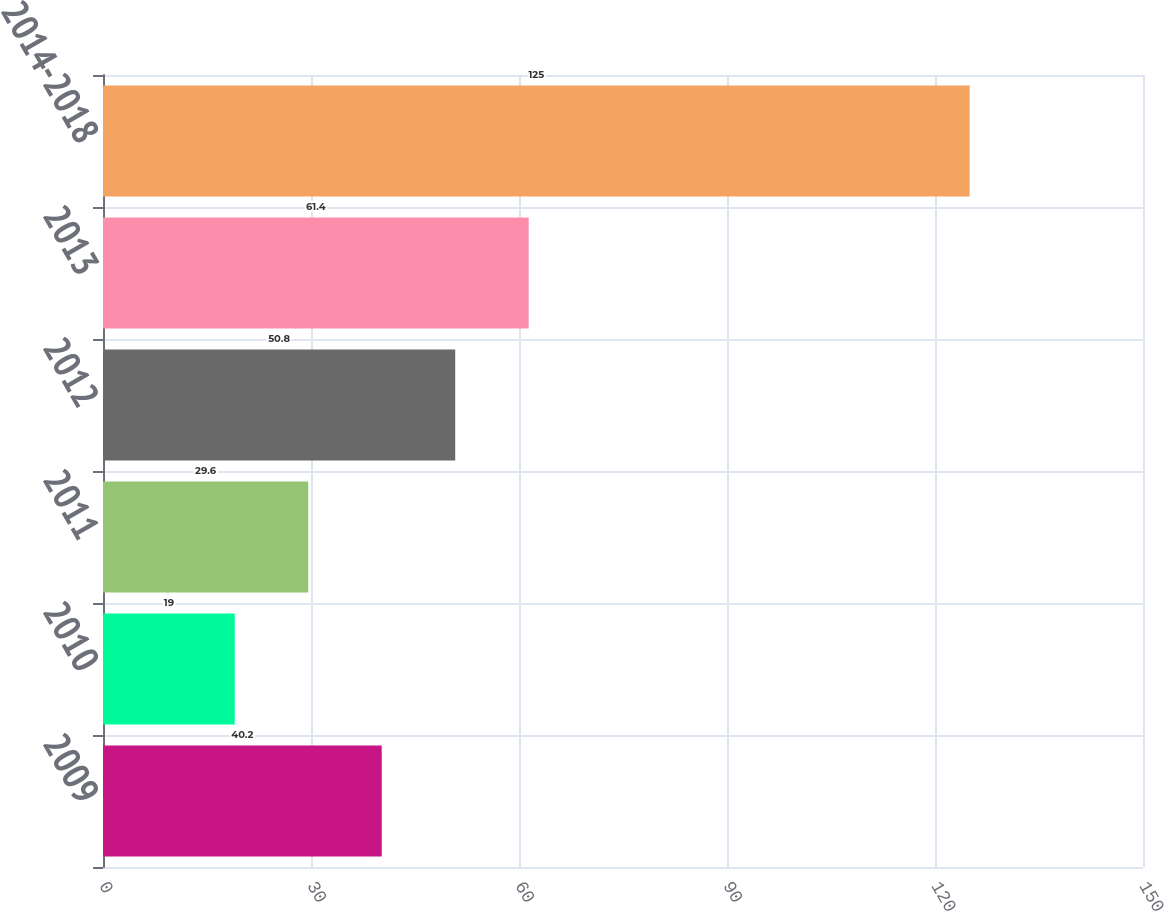Convert chart. <chart><loc_0><loc_0><loc_500><loc_500><bar_chart><fcel>2009<fcel>2010<fcel>2011<fcel>2012<fcel>2013<fcel>2014-2018<nl><fcel>40.2<fcel>19<fcel>29.6<fcel>50.8<fcel>61.4<fcel>125<nl></chart> 